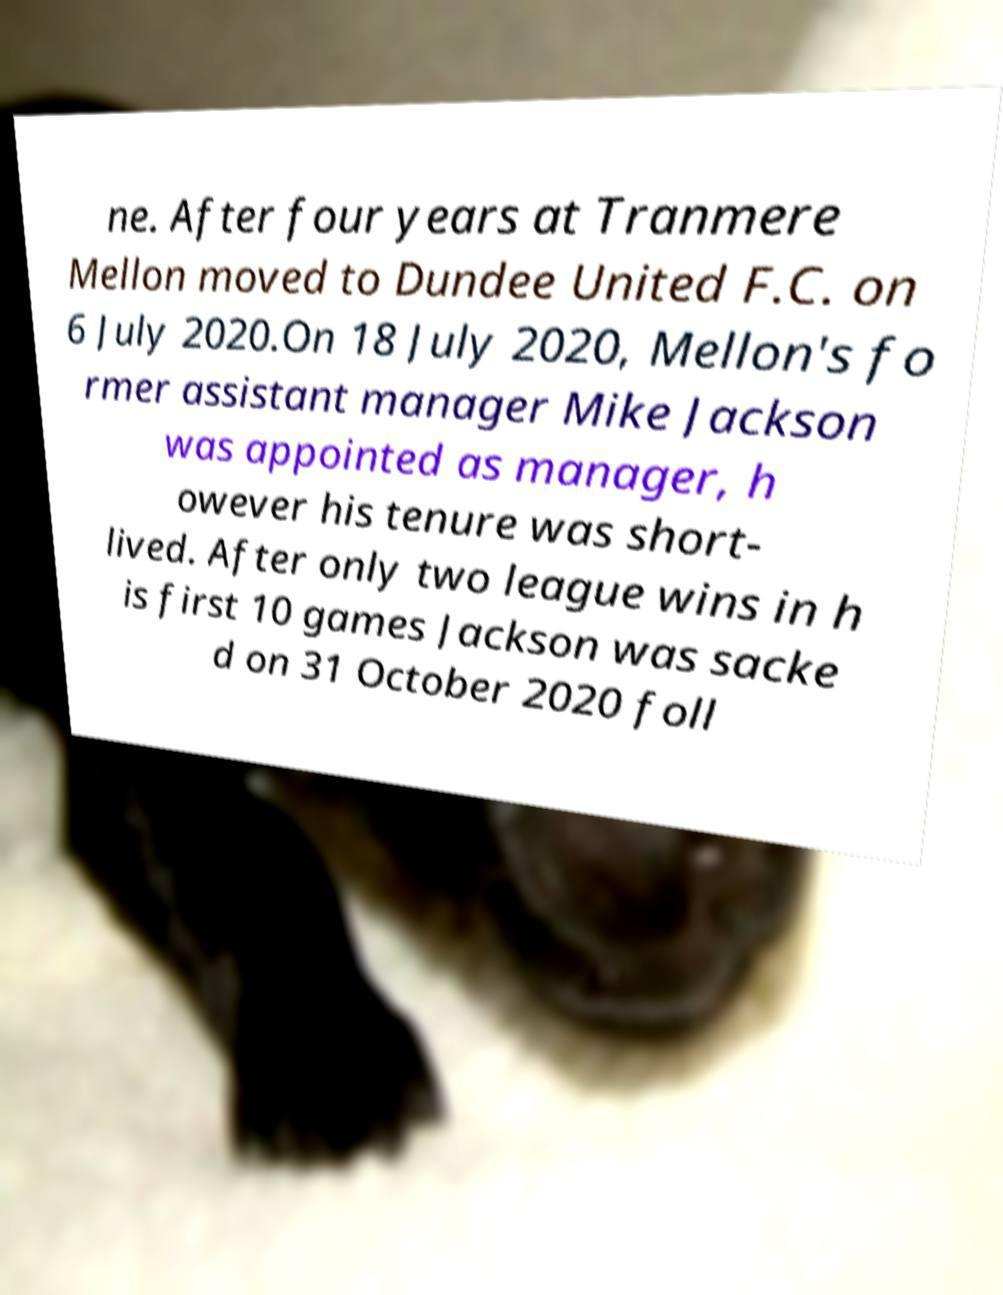For documentation purposes, I need the text within this image transcribed. Could you provide that? ne. After four years at Tranmere Mellon moved to Dundee United F.C. on 6 July 2020.On 18 July 2020, Mellon's fo rmer assistant manager Mike Jackson was appointed as manager, h owever his tenure was short- lived. After only two league wins in h is first 10 games Jackson was sacke d on 31 October 2020 foll 